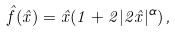<formula> <loc_0><loc_0><loc_500><loc_500>\hat { f } ( \hat { x } ) = \hat { x } ( 1 + 2 | 2 \hat { x } | ^ { \alpha } ) \, ,</formula> 